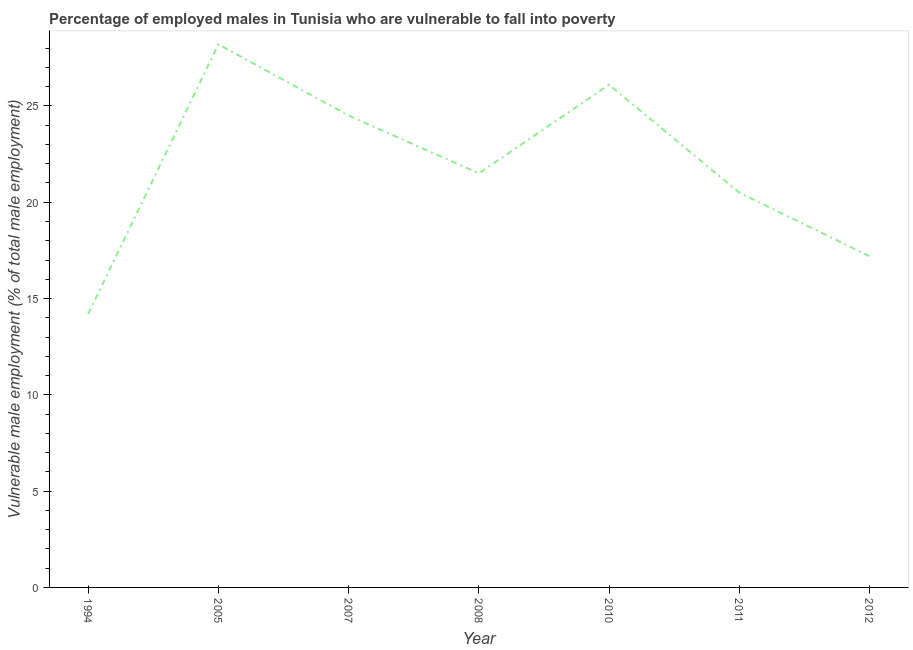Across all years, what is the maximum percentage of employed males who are vulnerable to fall into poverty?
Keep it short and to the point. 28.2. Across all years, what is the minimum percentage of employed males who are vulnerable to fall into poverty?
Give a very brief answer. 14.2. In which year was the percentage of employed males who are vulnerable to fall into poverty minimum?
Make the answer very short. 1994. What is the sum of the percentage of employed males who are vulnerable to fall into poverty?
Give a very brief answer. 152.2. What is the difference between the percentage of employed males who are vulnerable to fall into poverty in 1994 and 2007?
Your answer should be very brief. -10.3. What is the average percentage of employed males who are vulnerable to fall into poverty per year?
Make the answer very short. 21.74. Do a majority of the years between 1994 and 2008 (inclusive) have percentage of employed males who are vulnerable to fall into poverty greater than 22 %?
Provide a succinct answer. No. What is the ratio of the percentage of employed males who are vulnerable to fall into poverty in 1994 to that in 2010?
Offer a very short reply. 0.54. Is the percentage of employed males who are vulnerable to fall into poverty in 2010 less than that in 2011?
Provide a succinct answer. No. Is the difference between the percentage of employed males who are vulnerable to fall into poverty in 2005 and 2010 greater than the difference between any two years?
Offer a very short reply. No. What is the difference between the highest and the second highest percentage of employed males who are vulnerable to fall into poverty?
Offer a very short reply. 2.1. Is the sum of the percentage of employed males who are vulnerable to fall into poverty in 1994 and 2008 greater than the maximum percentage of employed males who are vulnerable to fall into poverty across all years?
Offer a terse response. Yes. What is the difference between the highest and the lowest percentage of employed males who are vulnerable to fall into poverty?
Offer a very short reply. 14. Does the percentage of employed males who are vulnerable to fall into poverty monotonically increase over the years?
Give a very brief answer. No. How many years are there in the graph?
Provide a short and direct response. 7. What is the difference between two consecutive major ticks on the Y-axis?
Your answer should be very brief. 5. What is the title of the graph?
Provide a short and direct response. Percentage of employed males in Tunisia who are vulnerable to fall into poverty. What is the label or title of the X-axis?
Ensure brevity in your answer.  Year. What is the label or title of the Y-axis?
Give a very brief answer. Vulnerable male employment (% of total male employment). What is the Vulnerable male employment (% of total male employment) in 1994?
Provide a succinct answer. 14.2. What is the Vulnerable male employment (% of total male employment) of 2005?
Provide a short and direct response. 28.2. What is the Vulnerable male employment (% of total male employment) in 2008?
Offer a terse response. 21.5. What is the Vulnerable male employment (% of total male employment) of 2010?
Provide a short and direct response. 26.1. What is the Vulnerable male employment (% of total male employment) in 2012?
Make the answer very short. 17.2. What is the difference between the Vulnerable male employment (% of total male employment) in 1994 and 2007?
Provide a succinct answer. -10.3. What is the difference between the Vulnerable male employment (% of total male employment) in 1994 and 2008?
Make the answer very short. -7.3. What is the difference between the Vulnerable male employment (% of total male employment) in 2005 and 2007?
Provide a succinct answer. 3.7. What is the difference between the Vulnerable male employment (% of total male employment) in 2005 and 2008?
Provide a succinct answer. 6.7. What is the difference between the Vulnerable male employment (% of total male employment) in 2005 and 2011?
Offer a very short reply. 7.7. What is the difference between the Vulnerable male employment (% of total male employment) in 2005 and 2012?
Provide a short and direct response. 11. What is the difference between the Vulnerable male employment (% of total male employment) in 2007 and 2011?
Provide a succinct answer. 4. What is the difference between the Vulnerable male employment (% of total male employment) in 2007 and 2012?
Your answer should be compact. 7.3. What is the ratio of the Vulnerable male employment (% of total male employment) in 1994 to that in 2005?
Provide a short and direct response. 0.5. What is the ratio of the Vulnerable male employment (% of total male employment) in 1994 to that in 2007?
Give a very brief answer. 0.58. What is the ratio of the Vulnerable male employment (% of total male employment) in 1994 to that in 2008?
Offer a terse response. 0.66. What is the ratio of the Vulnerable male employment (% of total male employment) in 1994 to that in 2010?
Your response must be concise. 0.54. What is the ratio of the Vulnerable male employment (% of total male employment) in 1994 to that in 2011?
Your response must be concise. 0.69. What is the ratio of the Vulnerable male employment (% of total male employment) in 1994 to that in 2012?
Keep it short and to the point. 0.83. What is the ratio of the Vulnerable male employment (% of total male employment) in 2005 to that in 2007?
Offer a very short reply. 1.15. What is the ratio of the Vulnerable male employment (% of total male employment) in 2005 to that in 2008?
Your response must be concise. 1.31. What is the ratio of the Vulnerable male employment (% of total male employment) in 2005 to that in 2011?
Your answer should be very brief. 1.38. What is the ratio of the Vulnerable male employment (% of total male employment) in 2005 to that in 2012?
Make the answer very short. 1.64. What is the ratio of the Vulnerable male employment (% of total male employment) in 2007 to that in 2008?
Your answer should be very brief. 1.14. What is the ratio of the Vulnerable male employment (% of total male employment) in 2007 to that in 2010?
Your answer should be very brief. 0.94. What is the ratio of the Vulnerable male employment (% of total male employment) in 2007 to that in 2011?
Your response must be concise. 1.2. What is the ratio of the Vulnerable male employment (% of total male employment) in 2007 to that in 2012?
Make the answer very short. 1.42. What is the ratio of the Vulnerable male employment (% of total male employment) in 2008 to that in 2010?
Your answer should be compact. 0.82. What is the ratio of the Vulnerable male employment (% of total male employment) in 2008 to that in 2011?
Make the answer very short. 1.05. What is the ratio of the Vulnerable male employment (% of total male employment) in 2010 to that in 2011?
Offer a terse response. 1.27. What is the ratio of the Vulnerable male employment (% of total male employment) in 2010 to that in 2012?
Make the answer very short. 1.52. What is the ratio of the Vulnerable male employment (% of total male employment) in 2011 to that in 2012?
Keep it short and to the point. 1.19. 